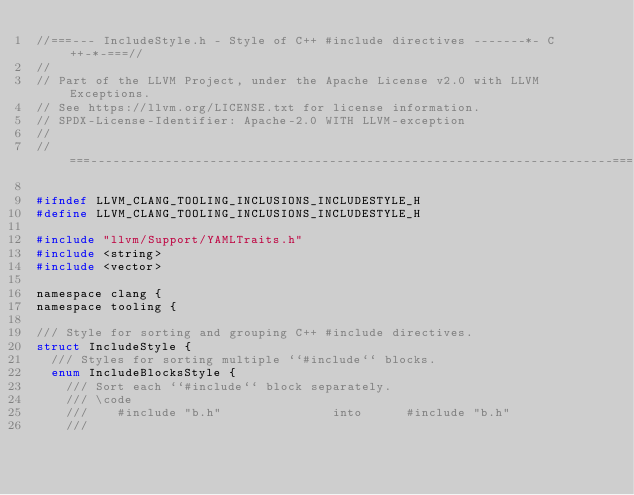<code> <loc_0><loc_0><loc_500><loc_500><_C_>//===--- IncludeStyle.h - Style of C++ #include directives -------*- C++-*-===//
//
// Part of the LLVM Project, under the Apache License v2.0 with LLVM Exceptions.
// See https://llvm.org/LICENSE.txt for license information.
// SPDX-License-Identifier: Apache-2.0 WITH LLVM-exception
//
//===----------------------------------------------------------------------===//

#ifndef LLVM_CLANG_TOOLING_INCLUSIONS_INCLUDESTYLE_H
#define LLVM_CLANG_TOOLING_INCLUSIONS_INCLUDESTYLE_H

#include "llvm/Support/YAMLTraits.h"
#include <string>
#include <vector>

namespace clang {
namespace tooling {

/// Style for sorting and grouping C++ #include directives.
struct IncludeStyle {
  /// Styles for sorting multiple ``#include`` blocks.
  enum IncludeBlocksStyle {
    /// Sort each ``#include`` block separately.
    /// \code
    ///    #include "b.h"               into      #include "b.h"
    ///</code> 